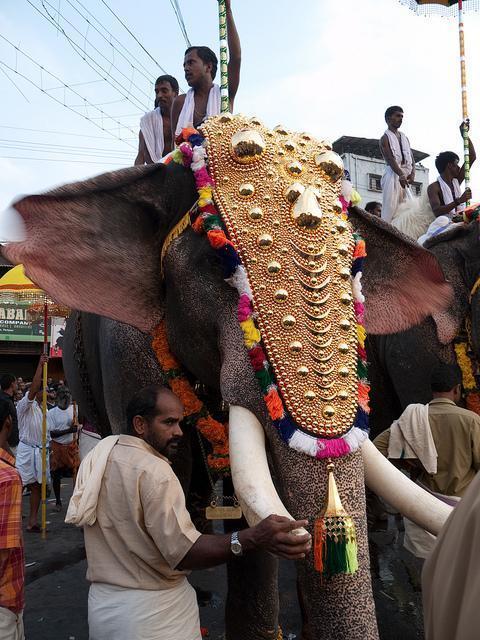How many elephants are there?
Give a very brief answer. 1. How many people are in the photo?
Give a very brief answer. 10. How many elephants are in the photo?
Give a very brief answer. 2. How many birds are in the background?
Give a very brief answer. 0. 